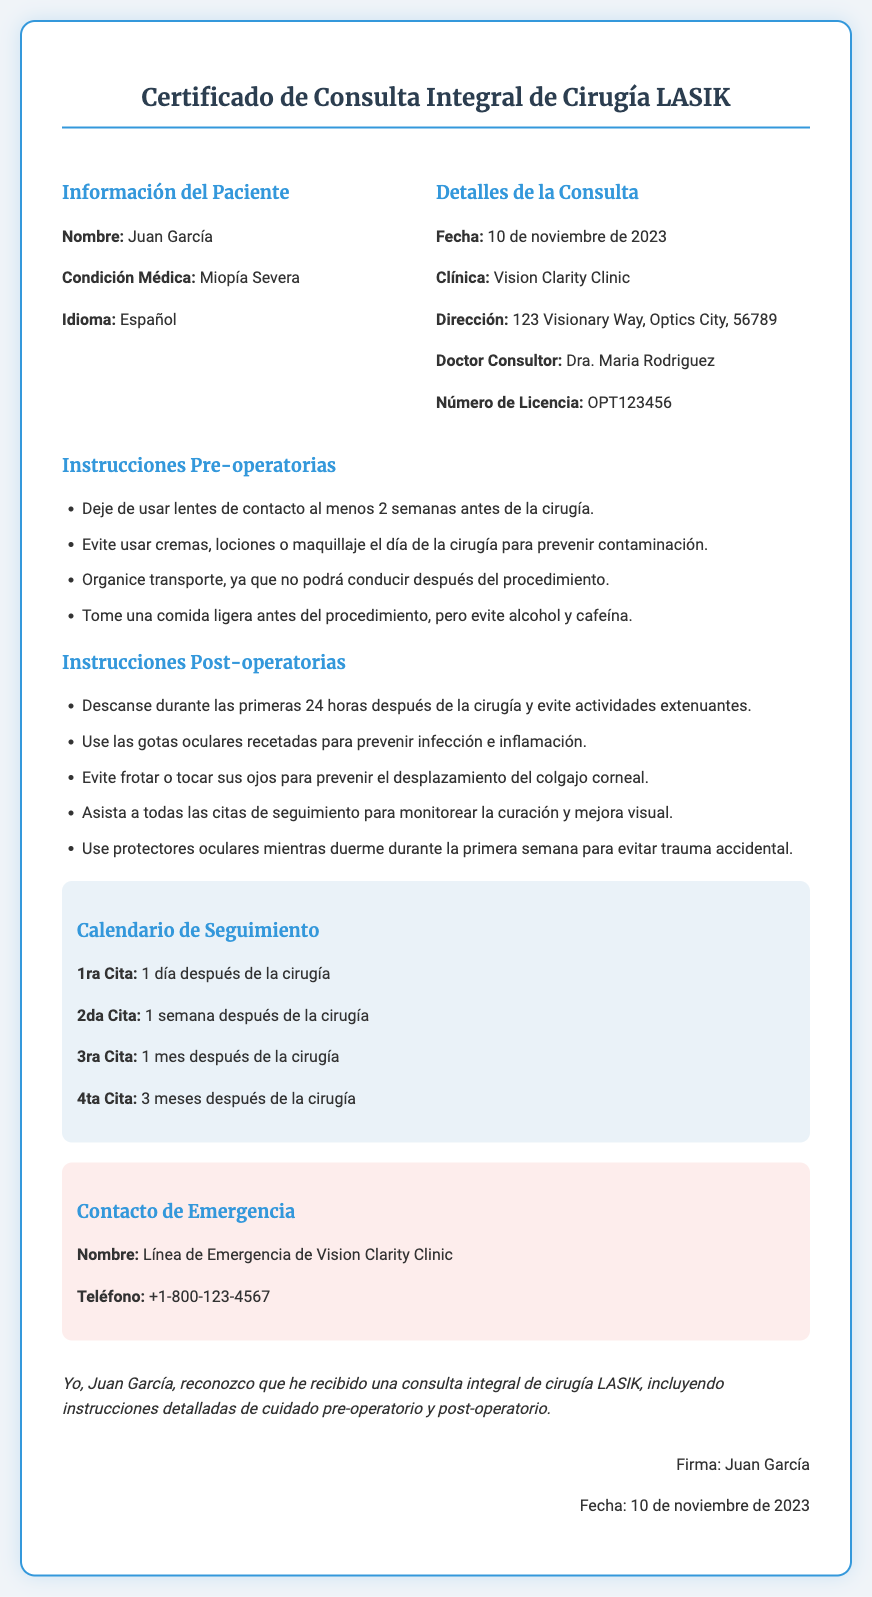¿Cuál es el nombre del paciente? El nombre del paciente se encuentra en la sección de información del paciente del documento.
Answer: Juan García ¿Qué condición médica tiene el paciente? La condición médica del paciente se menciona en la misma sección que su nombre.
Answer: Miopía Severa ¿Cuándo se realizó la consulta? La fecha de la consulta se indica en la sección de detalles de la consulta.
Answer: 10 de noviembre de 2023 ¿Quién fue el doctor consultor? El nombre del doctor consultor está listado en los detalles de la consulta.
Answer: Dra. Maria Rodriguez ¿Cuántas citas de seguimiento se mencionan? El número de citas de seguimiento se puede contar en la sección dedicada al calendario de seguimiento.
Answer: Cuatro ¿Qué se debe evitar el día de la cirugía? La sección de instrucciones pre-operatorias detalla lo que se debe evitar.
Answer: Cremas, lociones o maquillaje ¿Cuál es el número de contacto de emergencia? El número de contacto de emergencia se encuentra en la sección de contacto de emergencia.
Answer: +1-800-123-4567 ¿Qué debe hacer el paciente durante las primeras 24 horas post-operativas? Las instrucciones post-operatorias describen lo que se debe hacer.
Answer: Descansar ¿Dónde se encuentra la clínica? La dirección de la clínica está claramente mencionada en los detalles de la consulta.
Answer: 123 Visionary Way, Optics City, 56789 